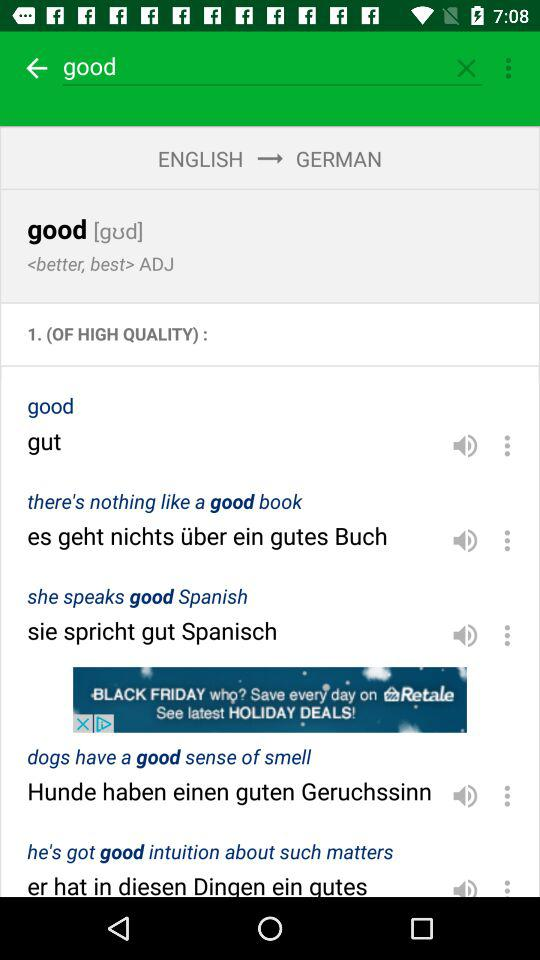Which word is entered in the search bar? The entered word in the search bar is "good". 